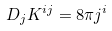<formula> <loc_0><loc_0><loc_500><loc_500>D _ { j } K ^ { i j } = 8 \pi j ^ { i }</formula> 